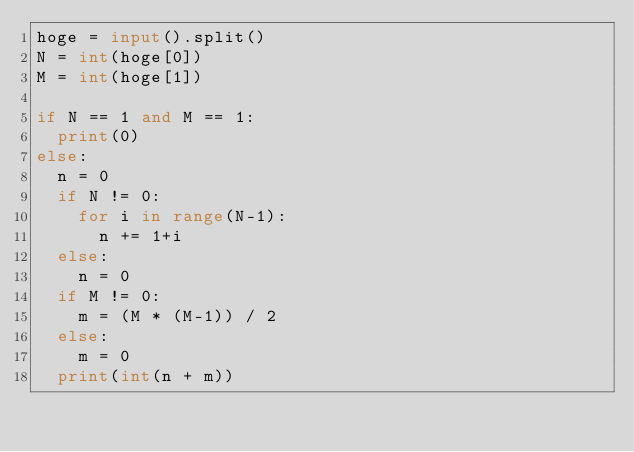<code> <loc_0><loc_0><loc_500><loc_500><_Python_>hoge = input().split()
N = int(hoge[0])
M = int(hoge[1])

if N == 1 and M == 1:
  print(0)
else:
  n = 0
  if N != 0:
    for i in range(N-1):
      n += 1+i
  else:
    n = 0
  if M != 0:
    m = (M * (M-1)) / 2
  else:
    m = 0
  print(int(n + m))</code> 